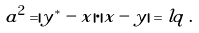Convert formula to latex. <formula><loc_0><loc_0><loc_500><loc_500>a ^ { 2 } = | y ^ { * } - x | \cdot | x - y | = l q \, .</formula> 